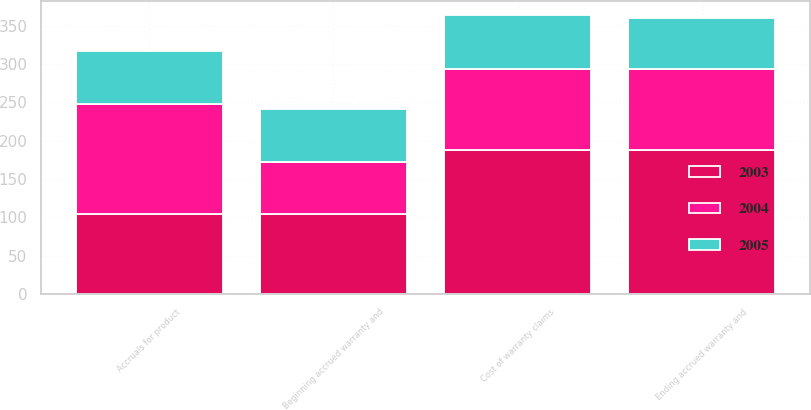Convert chart to OTSL. <chart><loc_0><loc_0><loc_500><loc_500><stacked_bar_chart><ecel><fcel>Beginning accrued warranty and<fcel>Cost of warranty claims<fcel>Accruals for product<fcel>Ending accrued warranty and<nl><fcel>2003<fcel>105<fcel>188<fcel>105<fcel>188<nl><fcel>2004<fcel>67<fcel>105<fcel>143<fcel>105<nl><fcel>2005<fcel>69<fcel>71<fcel>69<fcel>67<nl></chart> 